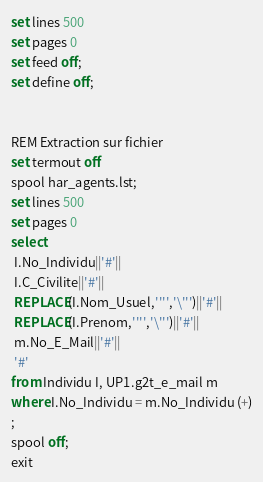Convert code to text. <code><loc_0><loc_0><loc_500><loc_500><_SQL_>set lines 500
set pages 0
set feed off;
set define off;


REM Extraction sur fichier
set termout off
spool har_agents.lst;
set lines 500
set pages 0
select 
 I.No_Individu||'#'||
 I.C_Civilite||'#'||
 REPLACE(I.Nom_Usuel,'''','\''')||'#'||
 REPLACE(I.Prenom,'''','\''')||'#'||
 m.No_E_Mail||'#'||
 '#'
from Individu I, UP1.g2t_e_mail m
where I.No_Individu = m.No_Individu (+)
;
spool off;
exit


</code> 